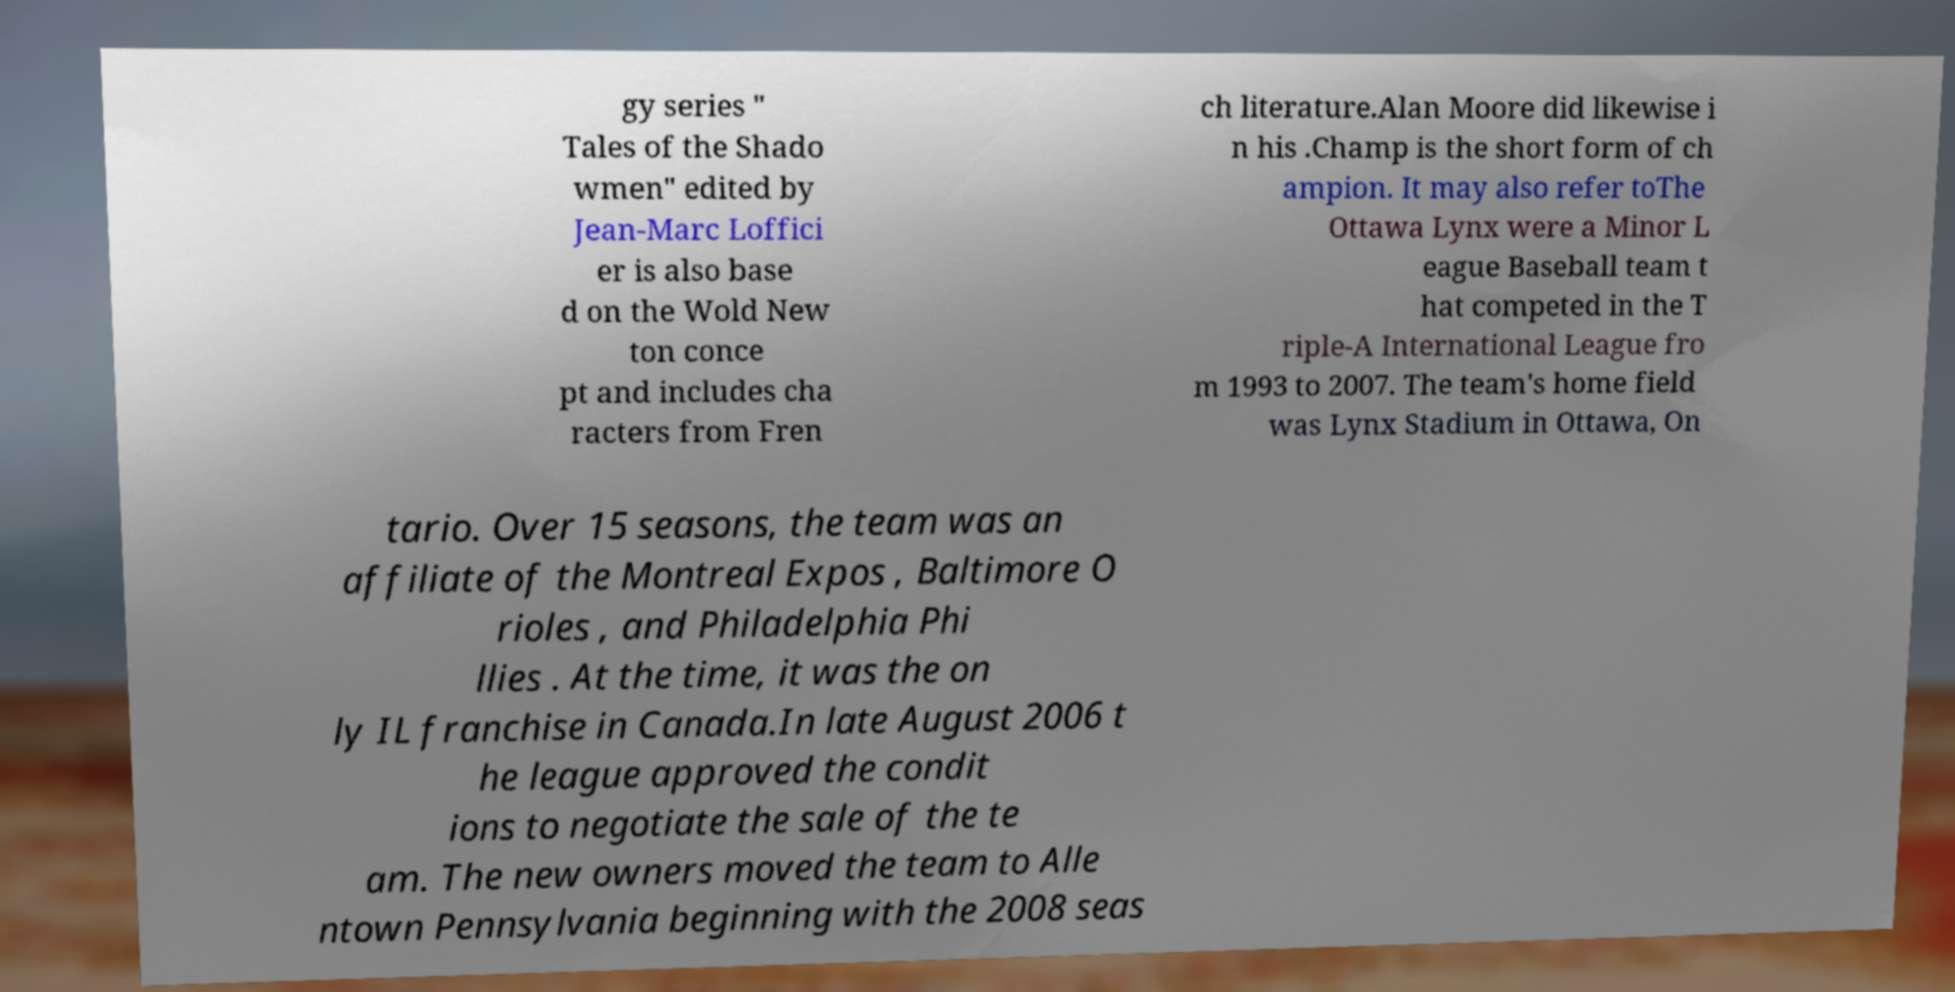I need the written content from this picture converted into text. Can you do that? gy series " Tales of the Shado wmen" edited by Jean-Marc Loffici er is also base d on the Wold New ton conce pt and includes cha racters from Fren ch literature.Alan Moore did likewise i n his .Champ is the short form of ch ampion. It may also refer toThe Ottawa Lynx were a Minor L eague Baseball team t hat competed in the T riple-A International League fro m 1993 to 2007. The team's home field was Lynx Stadium in Ottawa, On tario. Over 15 seasons, the team was an affiliate of the Montreal Expos , Baltimore O rioles , and Philadelphia Phi llies . At the time, it was the on ly IL franchise in Canada.In late August 2006 t he league approved the condit ions to negotiate the sale of the te am. The new owners moved the team to Alle ntown Pennsylvania beginning with the 2008 seas 